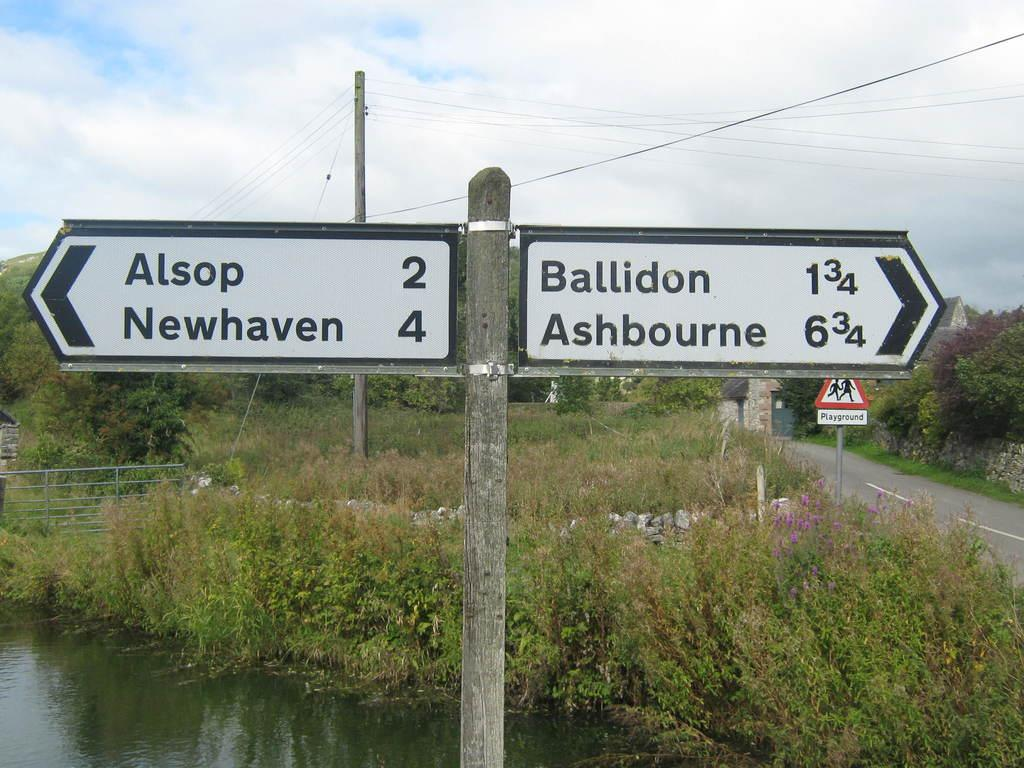<image>
Give a short and clear explanation of the subsequent image. A sign showing that Alsop and Newhaven are to the left. 